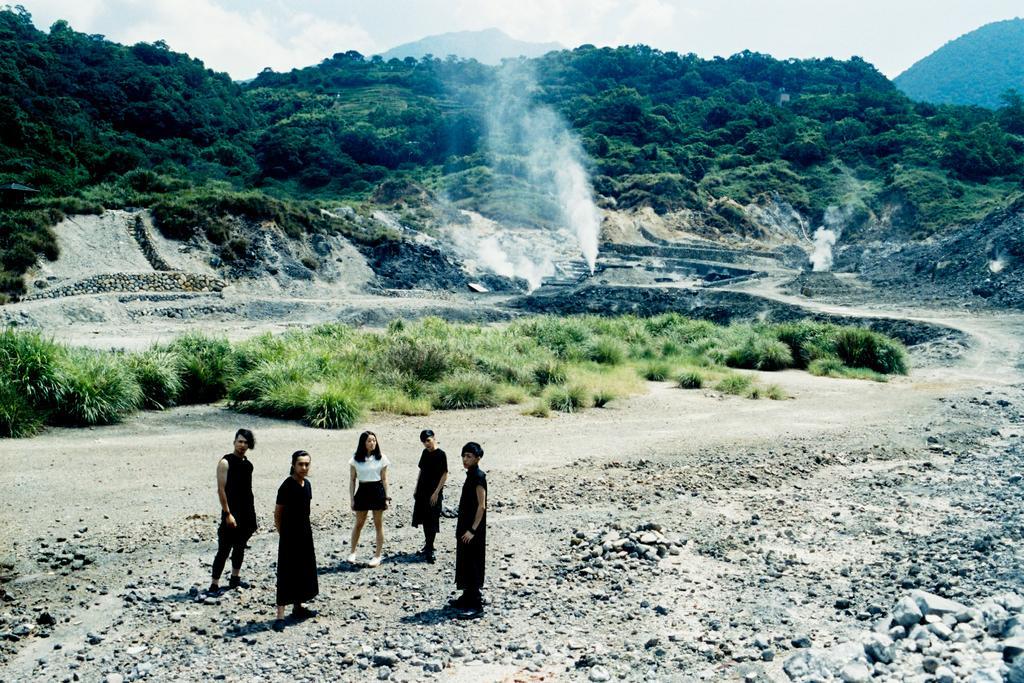How would you summarize this image in a sentence or two? This image consists of persons standing in the center. In the background there are plants, trees, mountains, and the sky is cloudy. 